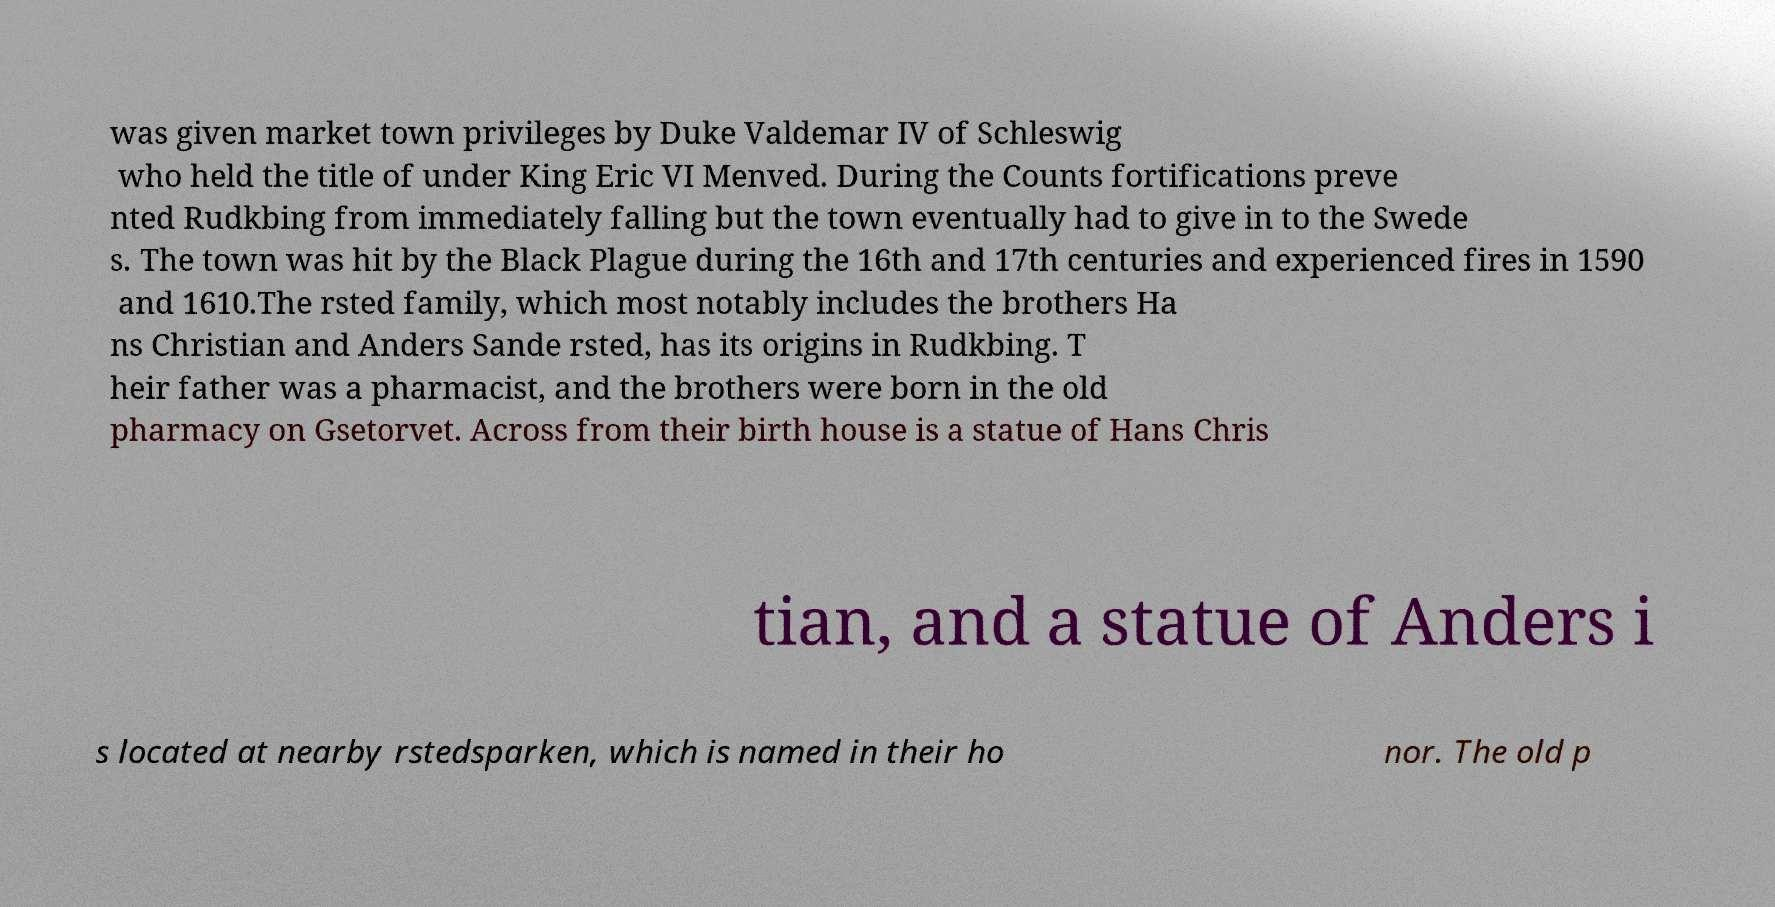I need the written content from this picture converted into text. Can you do that? was given market town privileges by Duke Valdemar IV of Schleswig who held the title of under King Eric VI Menved. During the Counts fortifications preve nted Rudkbing from immediately falling but the town eventually had to give in to the Swede s. The town was hit by the Black Plague during the 16th and 17th centuries and experienced fires in 1590 and 1610.The rsted family, which most notably includes the brothers Ha ns Christian and Anders Sande rsted, has its origins in Rudkbing. T heir father was a pharmacist, and the brothers were born in the old pharmacy on Gsetorvet. Across from their birth house is a statue of Hans Chris tian, and a statue of Anders i s located at nearby rstedsparken, which is named in their ho nor. The old p 